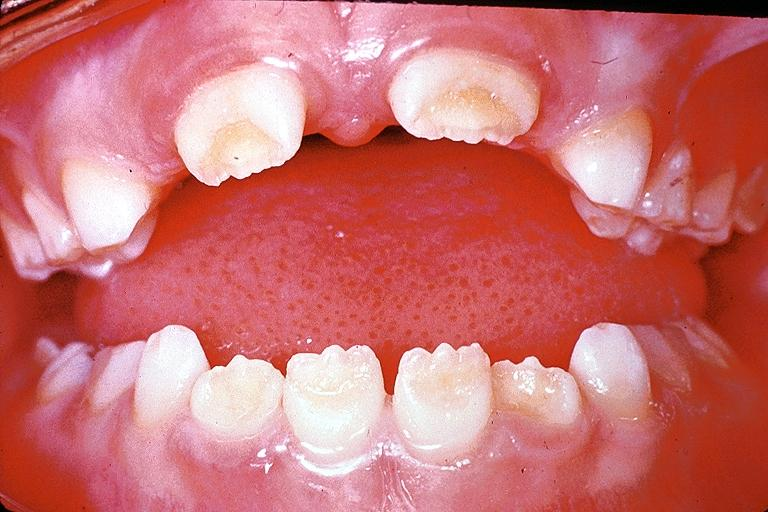does hydrocele show amelogenesis imperfecta?
Answer the question using a single word or phrase. No 